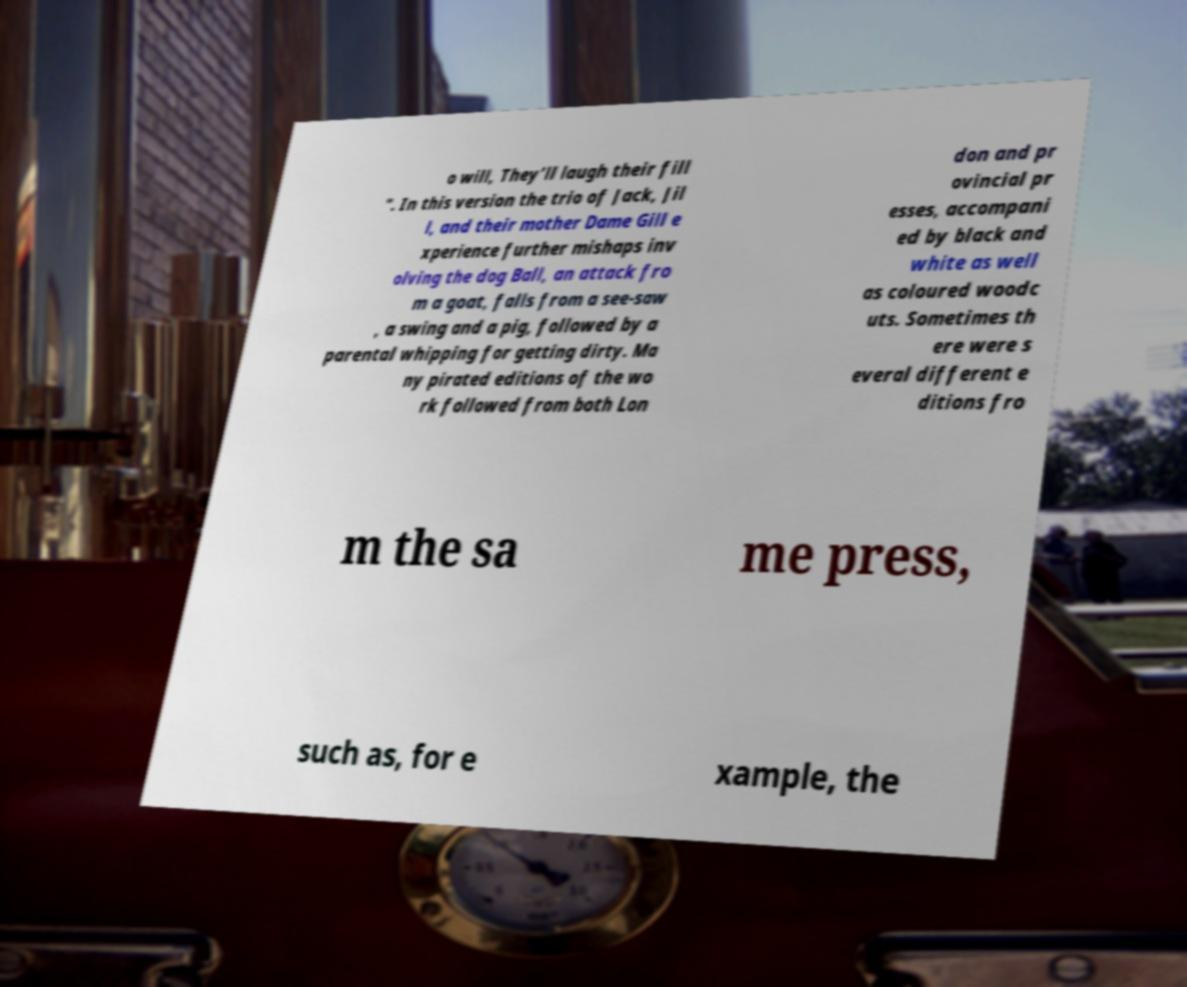Please read and relay the text visible in this image. What does it say? o will, They’ll laugh their fill ". In this version the trio of Jack, Jil l, and their mother Dame Gill e xperience further mishaps inv olving the dog Ball, an attack fro m a goat, falls from a see-saw , a swing and a pig, followed by a parental whipping for getting dirty. Ma ny pirated editions of the wo rk followed from both Lon don and pr ovincial pr esses, accompani ed by black and white as well as coloured woodc uts. Sometimes th ere were s everal different e ditions fro m the sa me press, such as, for e xample, the 